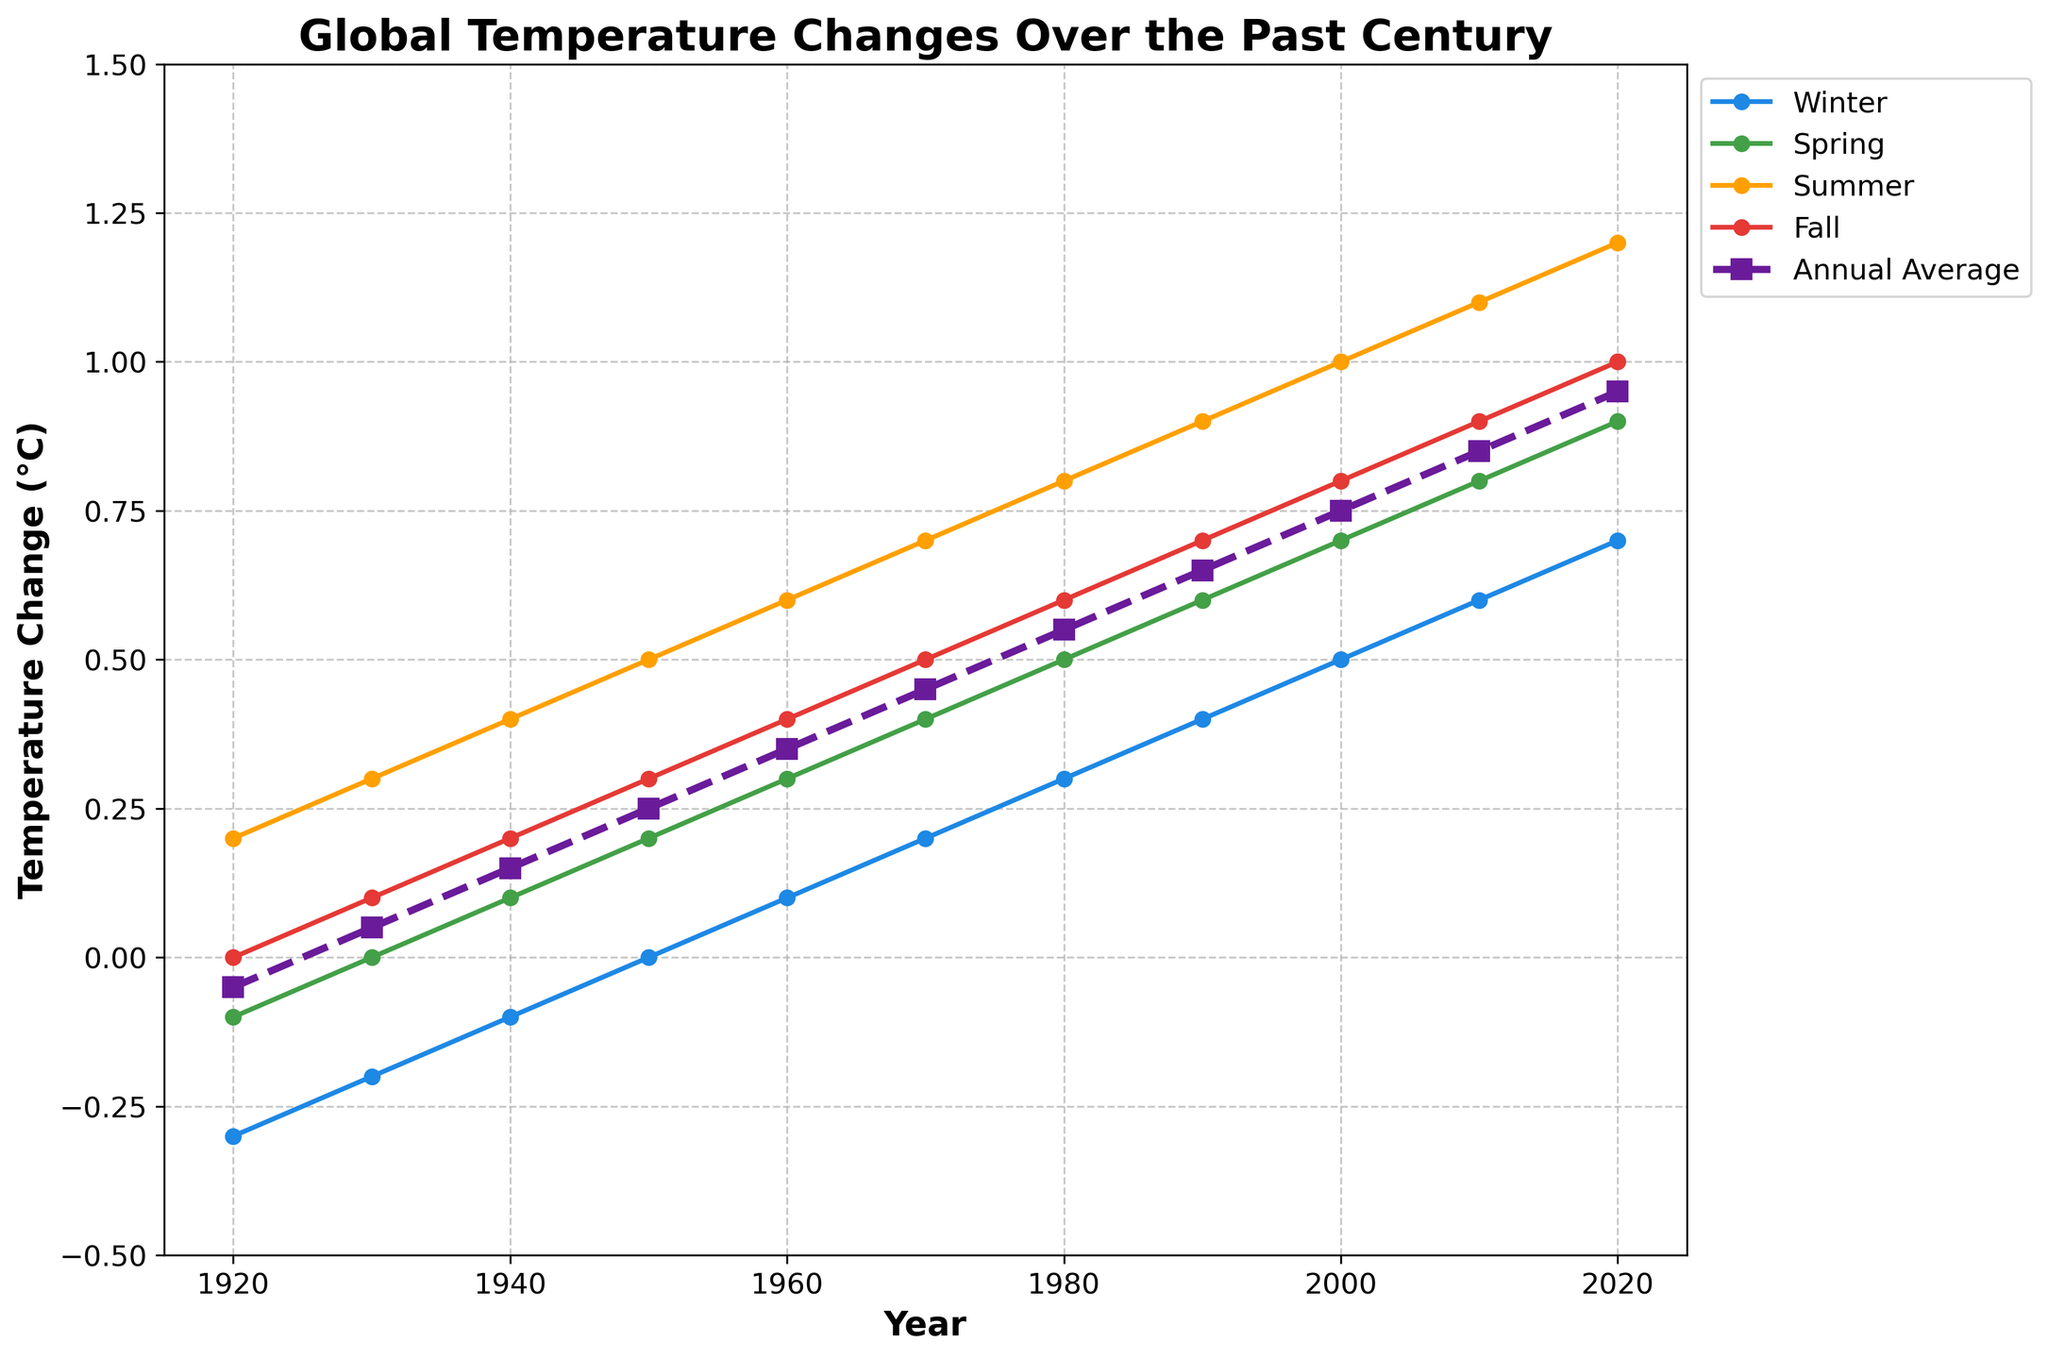What season has shown the most noticeable increase in temperature change over the past century? Looking at the plotted lines, Summer shows the steepest upward trend, indicating the most noticeable increase in temperature change from 1920 to 2020.
Answer: Summer In which decade does the Annual Average temperature first reach 0.5°C above the baseline? Observing the dashed line representing the Annual Average, it crosses the 0.5°C mark during the 1970s.
Answer: 1970s Which season consistently has the highest temperature change compared to the others? Comparing the heights of the four seasonal lines, the Summer line is consistently the highest throughout the entire century.
Answer: Summer Between 1920 and 2020, how much has the temperature change in Winter increased? The Winter temperature change in 1920 was -0.3°C, and it increased to 0.7°C by 2020. The difference is 0.7 - (-0.3) = 1.0°C.
Answer: 1.0°C If you average the temperature changes of all four seasons in 1960, how does it compare to the Annual Average for that year? Summing up the seasonal changes in 1960: 0.1 + 0.3 + 0.6 + 0.4 = 1.4. Averaging this: 1.4 / 4 = 0.35. The Annual Average for 1960 is 0.35°C, which matches the calculated average of the seasons.
Answer: Equal Which year shows the smallest difference in temperature change between Winter and Summer, and what is that difference? By inspecting the lines for Winter and Summer, the smallest difference is in 1920, where Winter is -0.3°C and Summer is 0.2°C. The difference is 0.2 - (-0.3) = 0.5°C.
Answer: 1920, 0.5°C During which period do Spring temperatures show a continuous increase without any decrease? The Spring temperature line shows a continuous increase from 1920 to 2020 without any decreases.
Answer: 1920-2020 Comparing the temperature change in Fall in the years 1950 and 2000, by how much has it increased? The Fall temperature change in 1950 was 0.3°C, and by 2000 it increased to 0.8°C. The difference is 0.8 - 0.3 = 0.5°C.
Answer: 0.5°C 